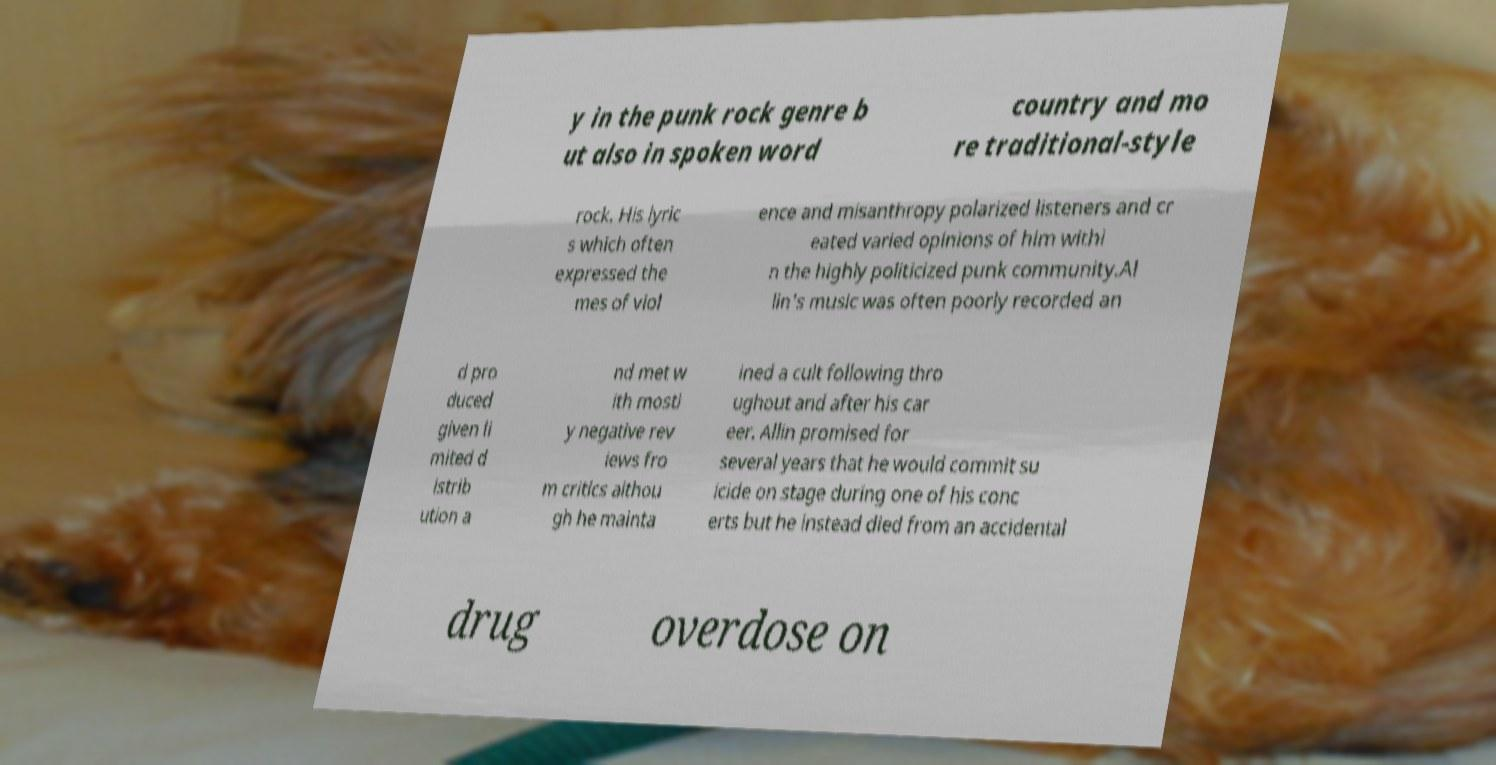Could you assist in decoding the text presented in this image and type it out clearly? y in the punk rock genre b ut also in spoken word country and mo re traditional-style rock. His lyric s which often expressed the mes of viol ence and misanthropy polarized listeners and cr eated varied opinions of him withi n the highly politicized punk community.Al lin's music was often poorly recorded an d pro duced given li mited d istrib ution a nd met w ith mostl y negative rev iews fro m critics althou gh he mainta ined a cult following thro ughout and after his car eer. Allin promised for several years that he would commit su icide on stage during one of his conc erts but he instead died from an accidental drug overdose on 